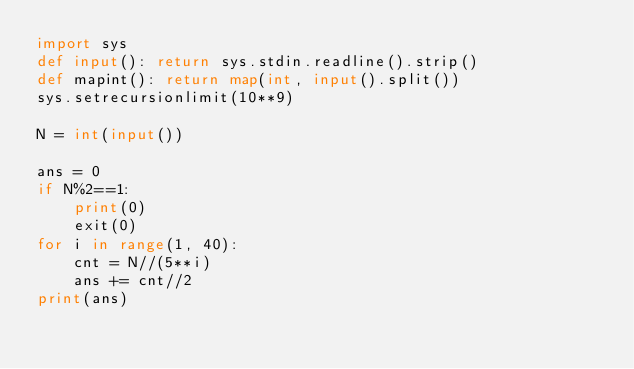Convert code to text. <code><loc_0><loc_0><loc_500><loc_500><_Python_>import sys
def input(): return sys.stdin.readline().strip()
def mapint(): return map(int, input().split())
sys.setrecursionlimit(10**9)

N = int(input())

ans = 0
if N%2==1:
    print(0)
    exit(0)
for i in range(1, 40):
    cnt = N//(5**i)
    ans += cnt//2
print(ans)</code> 